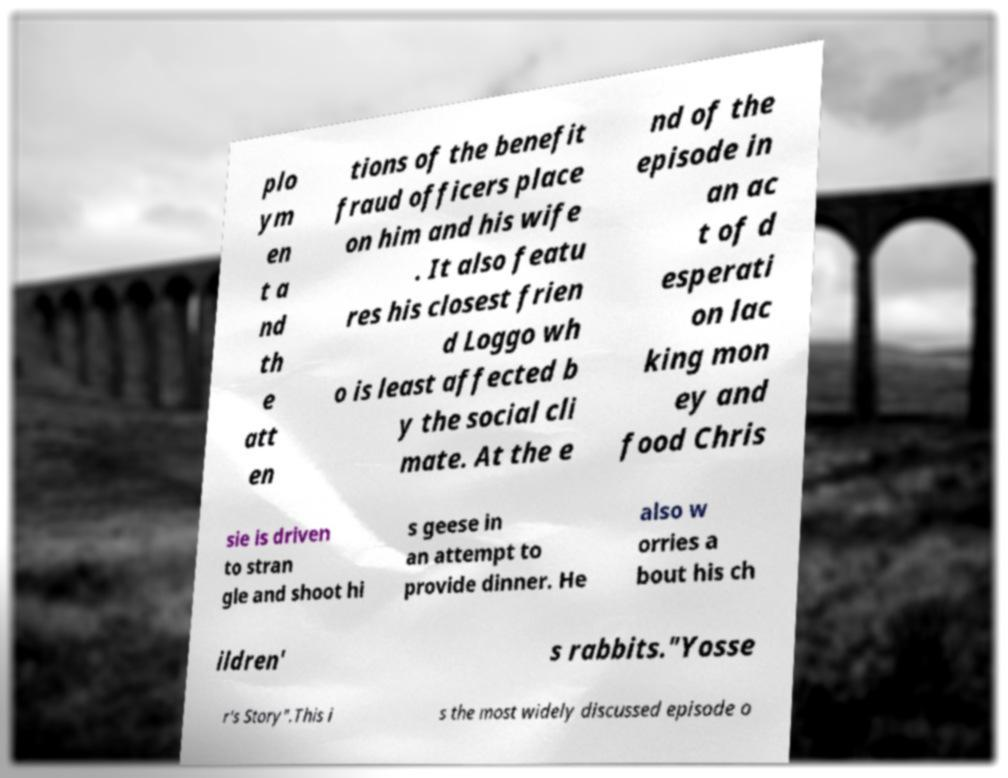Could you assist in decoding the text presented in this image and type it out clearly? plo ym en t a nd th e att en tions of the benefit fraud officers place on him and his wife . It also featu res his closest frien d Loggo wh o is least affected b y the social cli mate. At the e nd of the episode in an ac t of d esperati on lac king mon ey and food Chris sie is driven to stran gle and shoot hi s geese in an attempt to provide dinner. He also w orries a bout his ch ildren' s rabbits."Yosse r's Story".This i s the most widely discussed episode o 